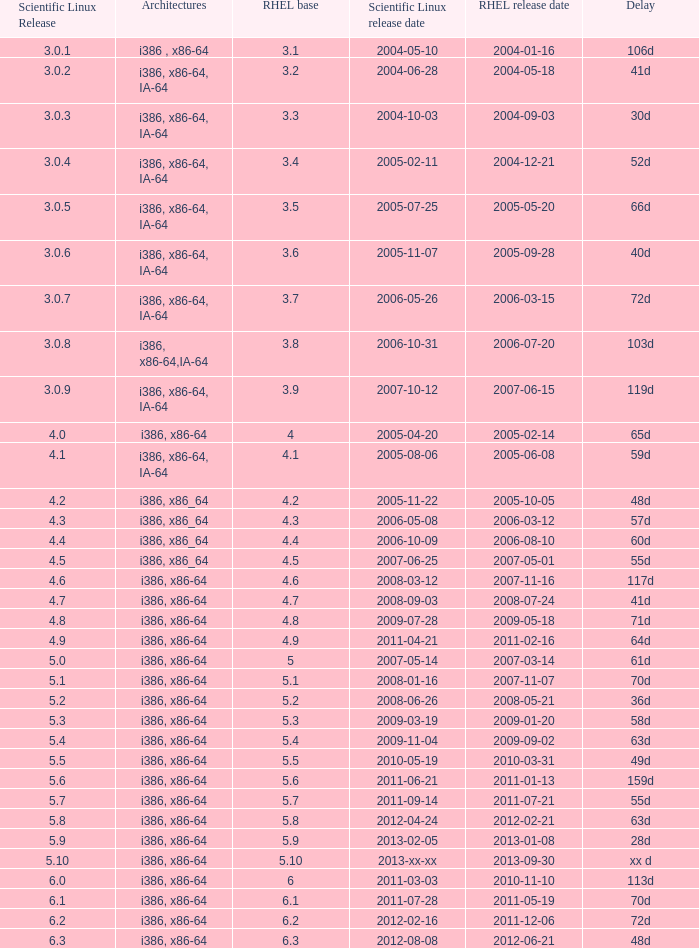Identify the scientific linux version when the postponement is 28 days. 5.9. 